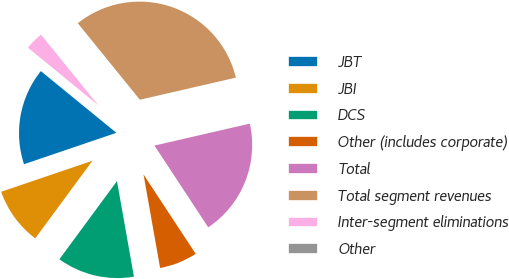Convert chart to OTSL. <chart><loc_0><loc_0><loc_500><loc_500><pie_chart><fcel>JBT<fcel>JBI<fcel>DCS<fcel>Other (includes corporate)<fcel>Total<fcel>Total segment revenues<fcel>Inter-segment eliminations<fcel>Other<nl><fcel>16.12%<fcel>9.68%<fcel>12.9%<fcel>6.46%<fcel>19.35%<fcel>32.24%<fcel>3.24%<fcel>0.01%<nl></chart> 